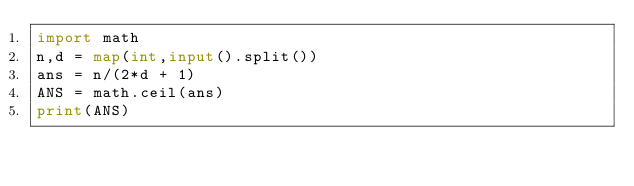<code> <loc_0><loc_0><loc_500><loc_500><_Python_>import math
n,d = map(int,input().split())
ans = n/(2*d + 1)
ANS = math.ceil(ans)
print(ANS)</code> 